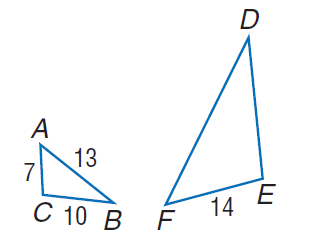Question: Find the perimeter of \triangle D E F, if \triangle D E F \sim \triangle A C B.
Choices:
A. 28
B. 30
C. 42
D. 49
Answer with the letter. Answer: C 